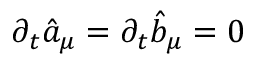<formula> <loc_0><loc_0><loc_500><loc_500>\partial _ { t } \hat { a } _ { \mu } = \partial _ { t } \hat { b } _ { \mu } = 0</formula> 